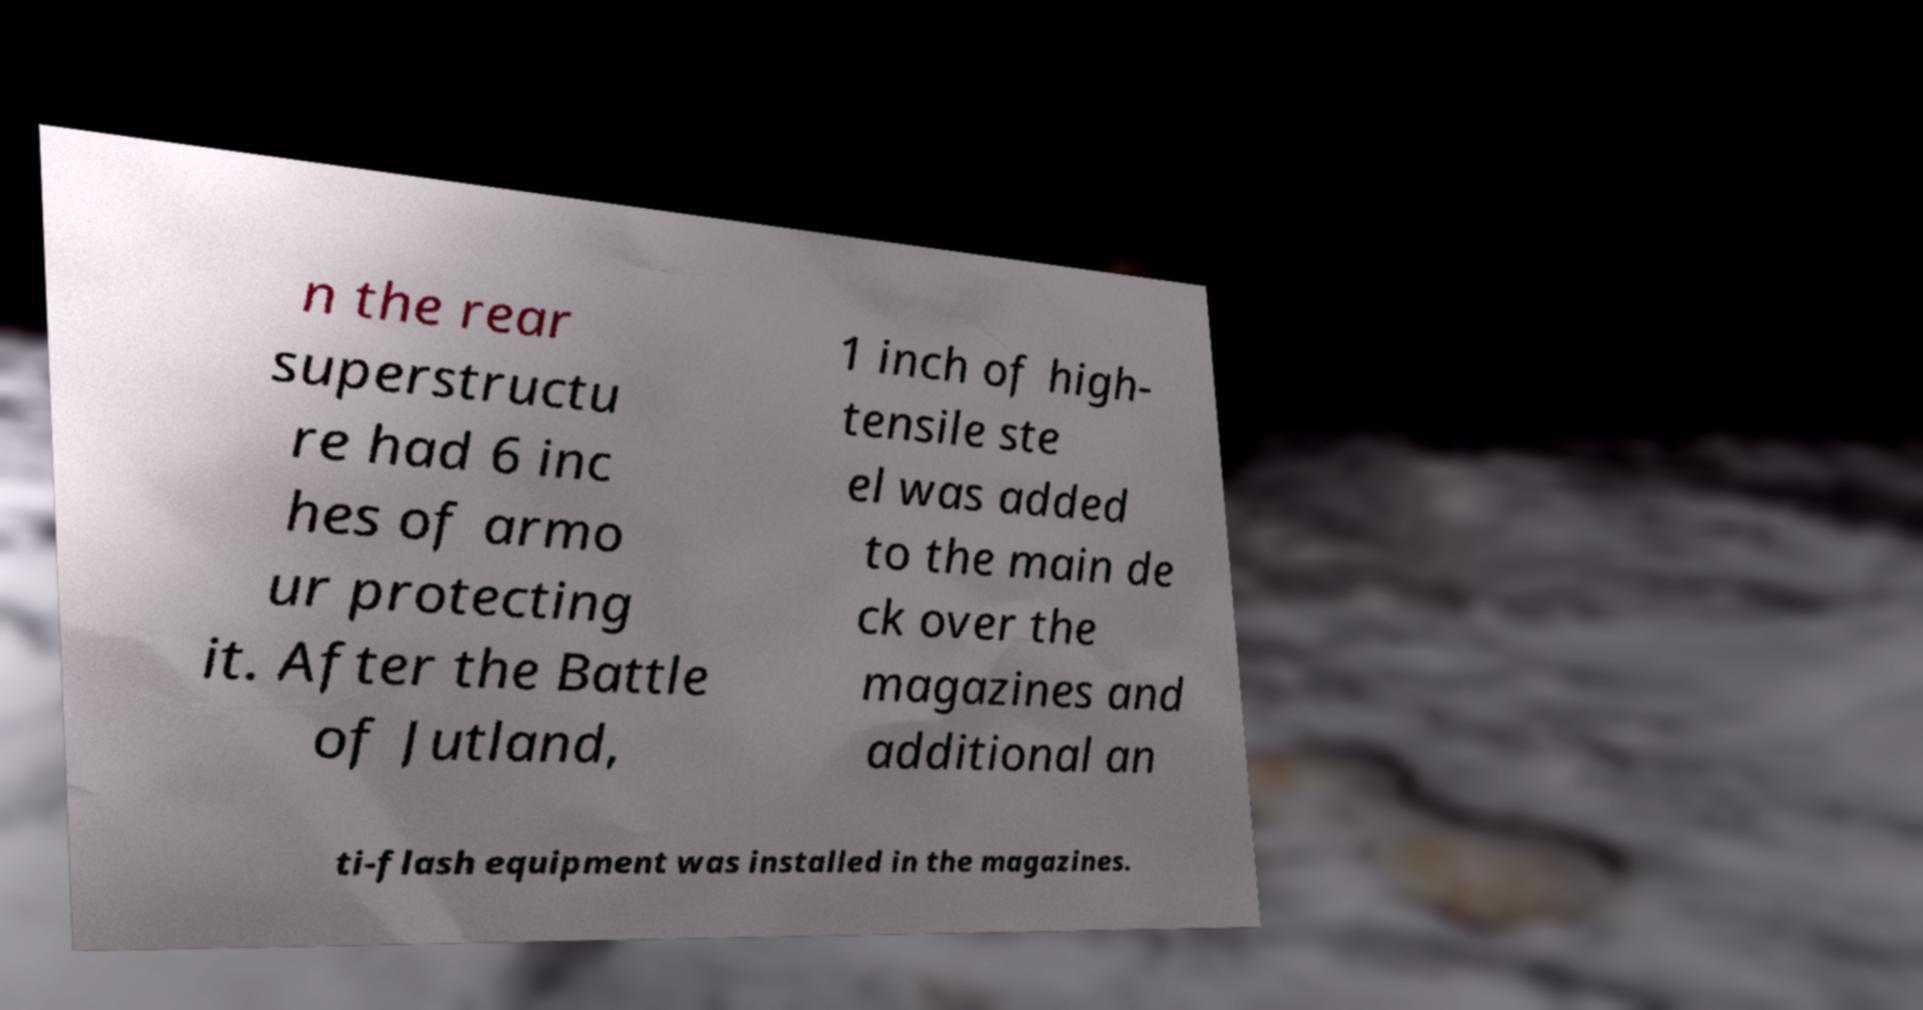Can you accurately transcribe the text from the provided image for me? n the rear superstructu re had 6 inc hes of armo ur protecting it. After the Battle of Jutland, 1 inch of high- tensile ste el was added to the main de ck over the magazines and additional an ti-flash equipment was installed in the magazines. 